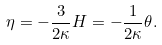Convert formula to latex. <formula><loc_0><loc_0><loc_500><loc_500>\eta = - \frac { 3 } { 2 \kappa } H = - \frac { 1 } { 2 \kappa } \theta .</formula> 